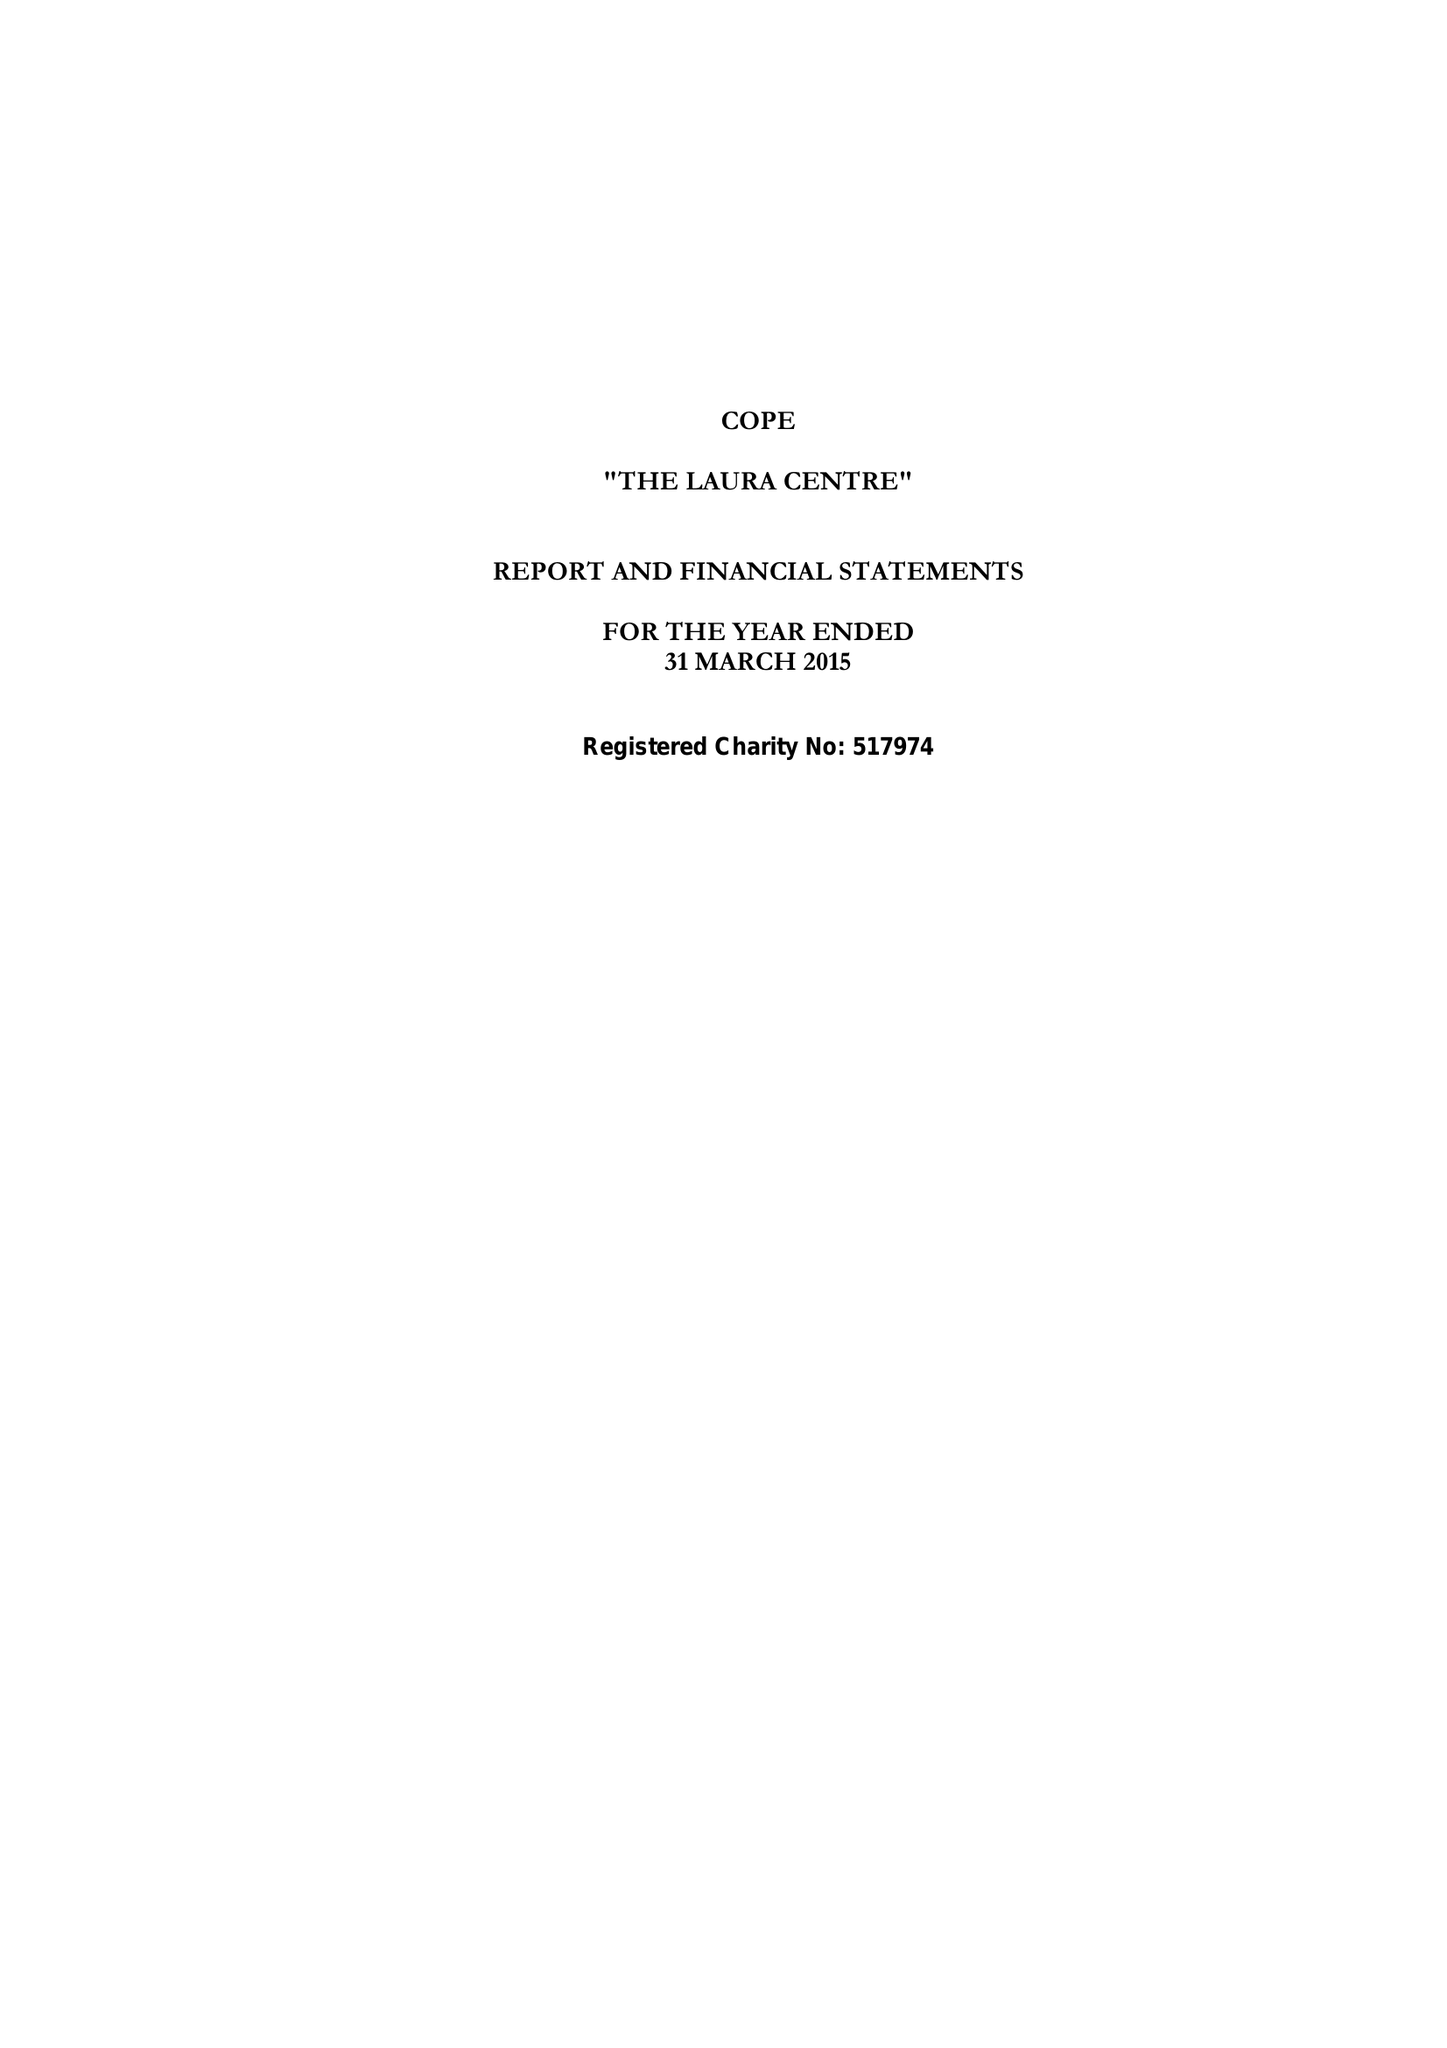What is the value for the address__postcode?
Answer the question using a single word or phrase. LE1 6WS 